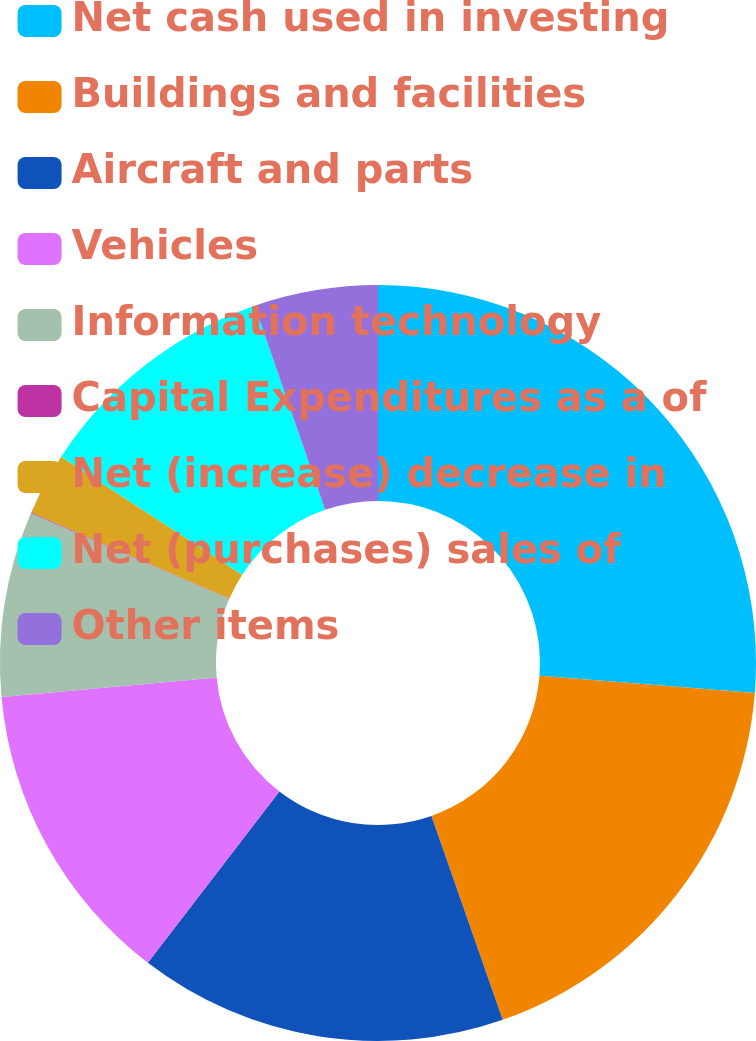<chart> <loc_0><loc_0><loc_500><loc_500><pie_chart><fcel>Net cash used in investing<fcel>Buildings and facilities<fcel>Aircraft and parts<fcel>Vehicles<fcel>Information technology<fcel>Capital Expenditures as a of<fcel>Net (increase) decrease in<fcel>Net (purchases) sales of<fcel>Other items<nl><fcel>26.26%<fcel>18.39%<fcel>15.77%<fcel>13.15%<fcel>7.91%<fcel>0.04%<fcel>2.66%<fcel>10.53%<fcel>5.29%<nl></chart> 